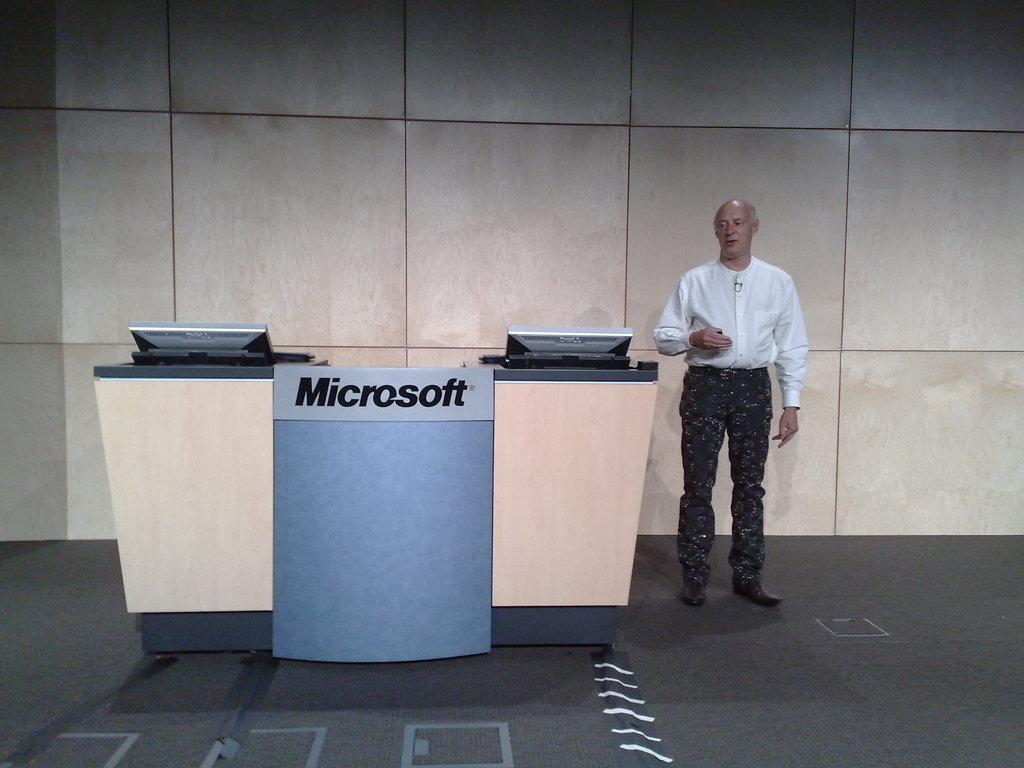Provide a one-sentence caption for the provided image. A man is standing by the Microsoft products booth. 